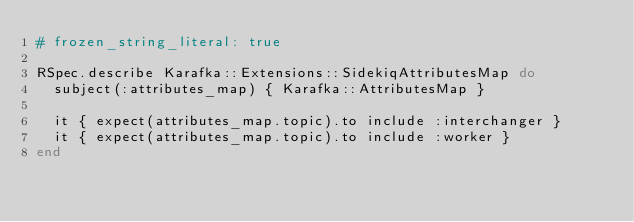<code> <loc_0><loc_0><loc_500><loc_500><_Ruby_># frozen_string_literal: true

RSpec.describe Karafka::Extensions::SidekiqAttributesMap do
  subject(:attributes_map) { Karafka::AttributesMap }

  it { expect(attributes_map.topic).to include :interchanger }
  it { expect(attributes_map.topic).to include :worker }
end
</code> 